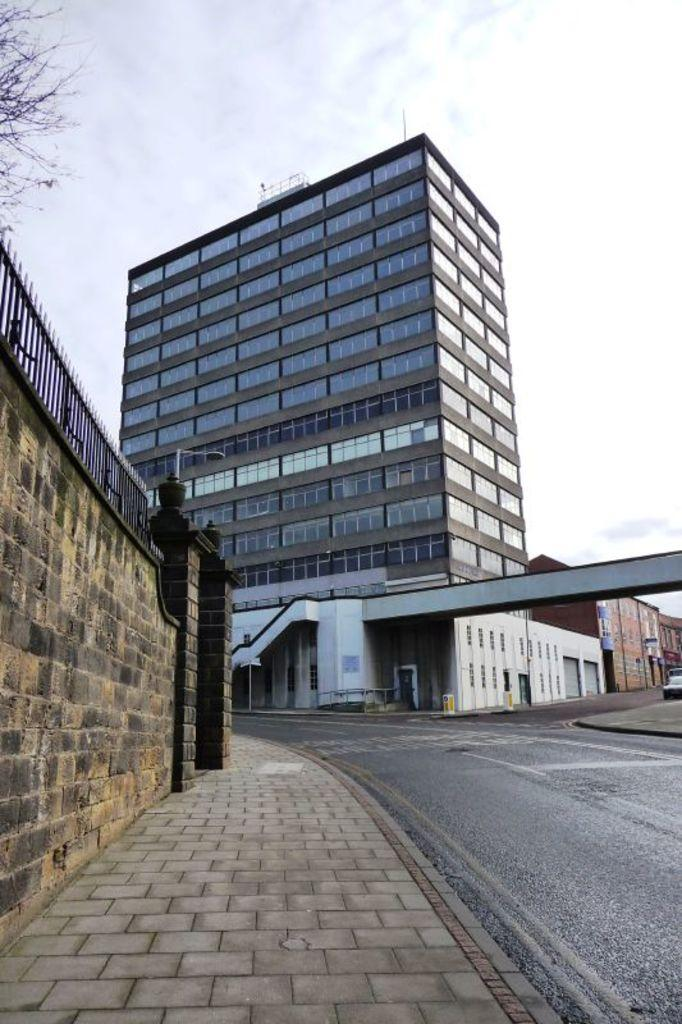What type of structures can be seen in the image? There are buildings in the image. What is the purpose of the road in the image? The road in the image is likely for transportation. What is the surface material of the area near the road? There is a pavement in the image. What is the purpose of the wall in the image? The wall in the image could serve as a boundary or for structural support. What type of vegetation is on the left side of the image? There is a tree on the left side of the image. What is visible in the background of the image? The sky is visible in the background of the image. Can you see any giraffes walking on the pavement in the image? There are no giraffes present in the image; it features buildings, a road, a pavement, a wall, a tree, and the sky. What type of shoes are the buildings wearing in the image? Buildings do not wear shoes, as they are inanimate structures. 